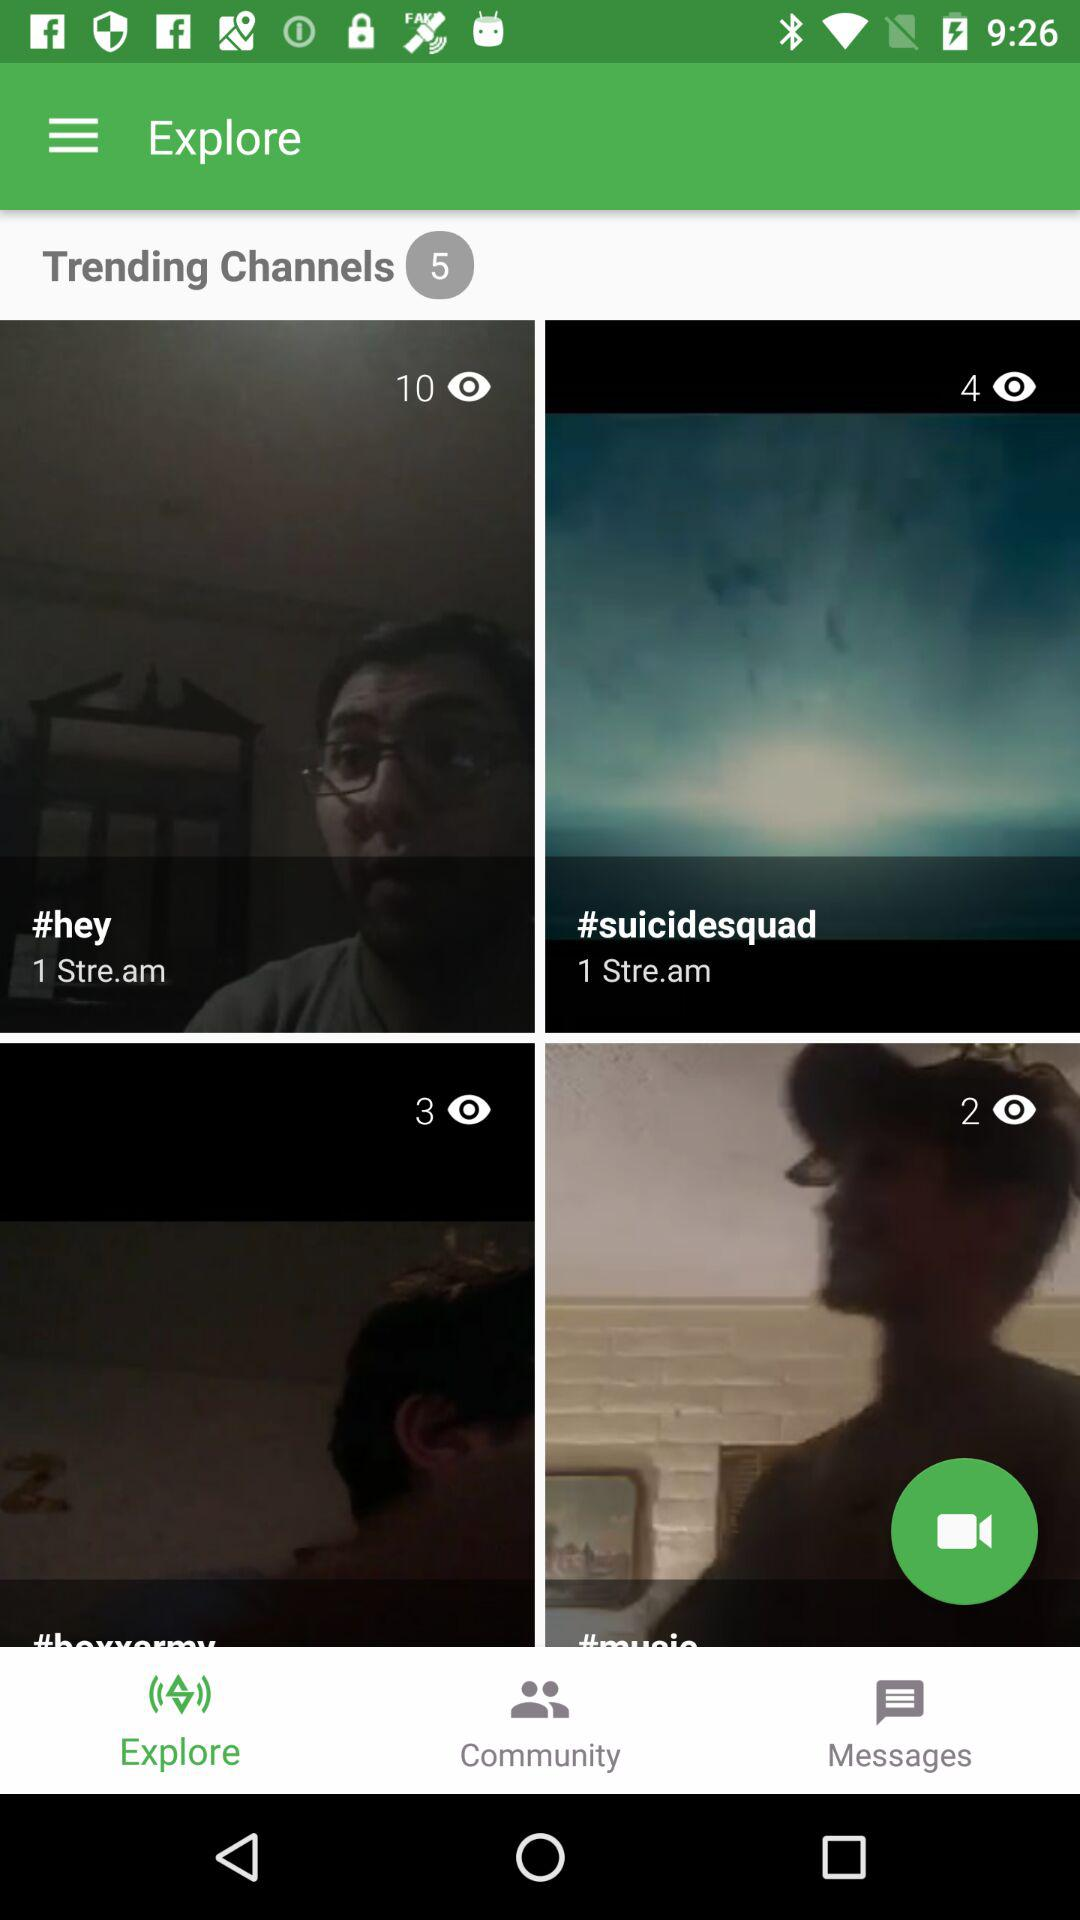How many items have the text '1 Stre.am'?
Answer the question using a single word or phrase. 2 